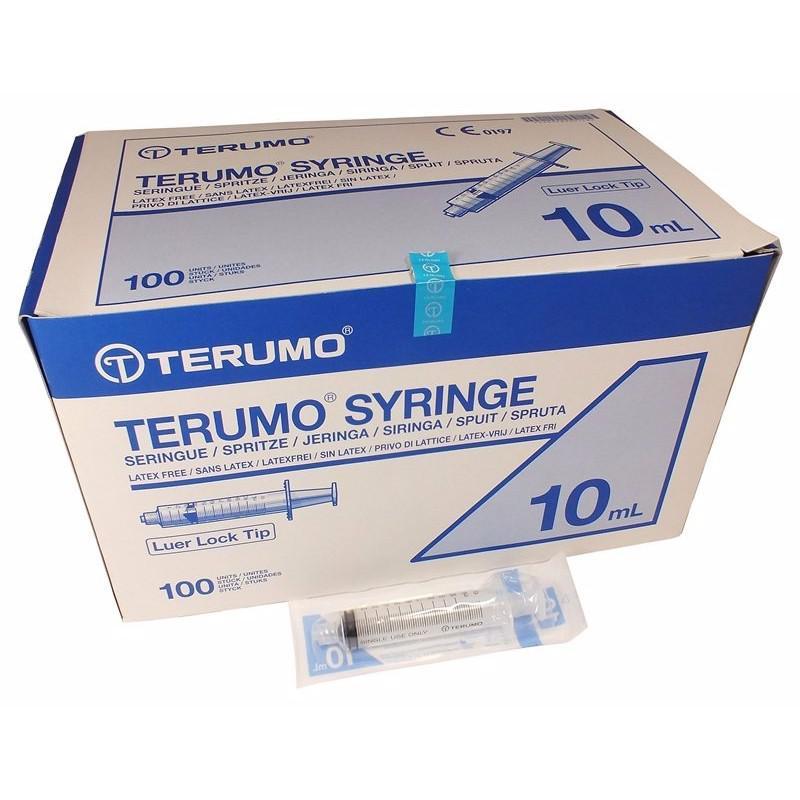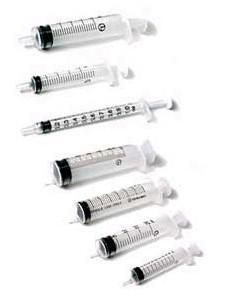The first image is the image on the left, the second image is the image on the right. Assess this claim about the two images: "At least one packaged syringe is in front of a box, in one image.". Correct or not? Answer yes or no. Yes. The first image is the image on the left, the second image is the image on the right. Assess this claim about the two images: "The left image has at least one syringe laying down in front of a box.". Correct or not? Answer yes or no. Yes. 